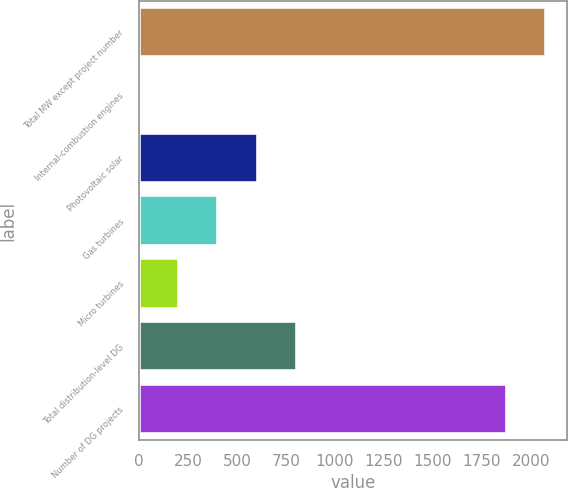Convert chart. <chart><loc_0><loc_0><loc_500><loc_500><bar_chart><fcel>Total MW except project number<fcel>Internal-combustion engines<fcel>Photovoltaic solar<fcel>Gas turbines<fcel>Micro turbines<fcel>Total distribution-level DG<fcel>Number of DG projects<nl><fcel>2078.3<fcel>1<fcel>604.9<fcel>403.6<fcel>202.3<fcel>806.2<fcel>1877<nl></chart> 